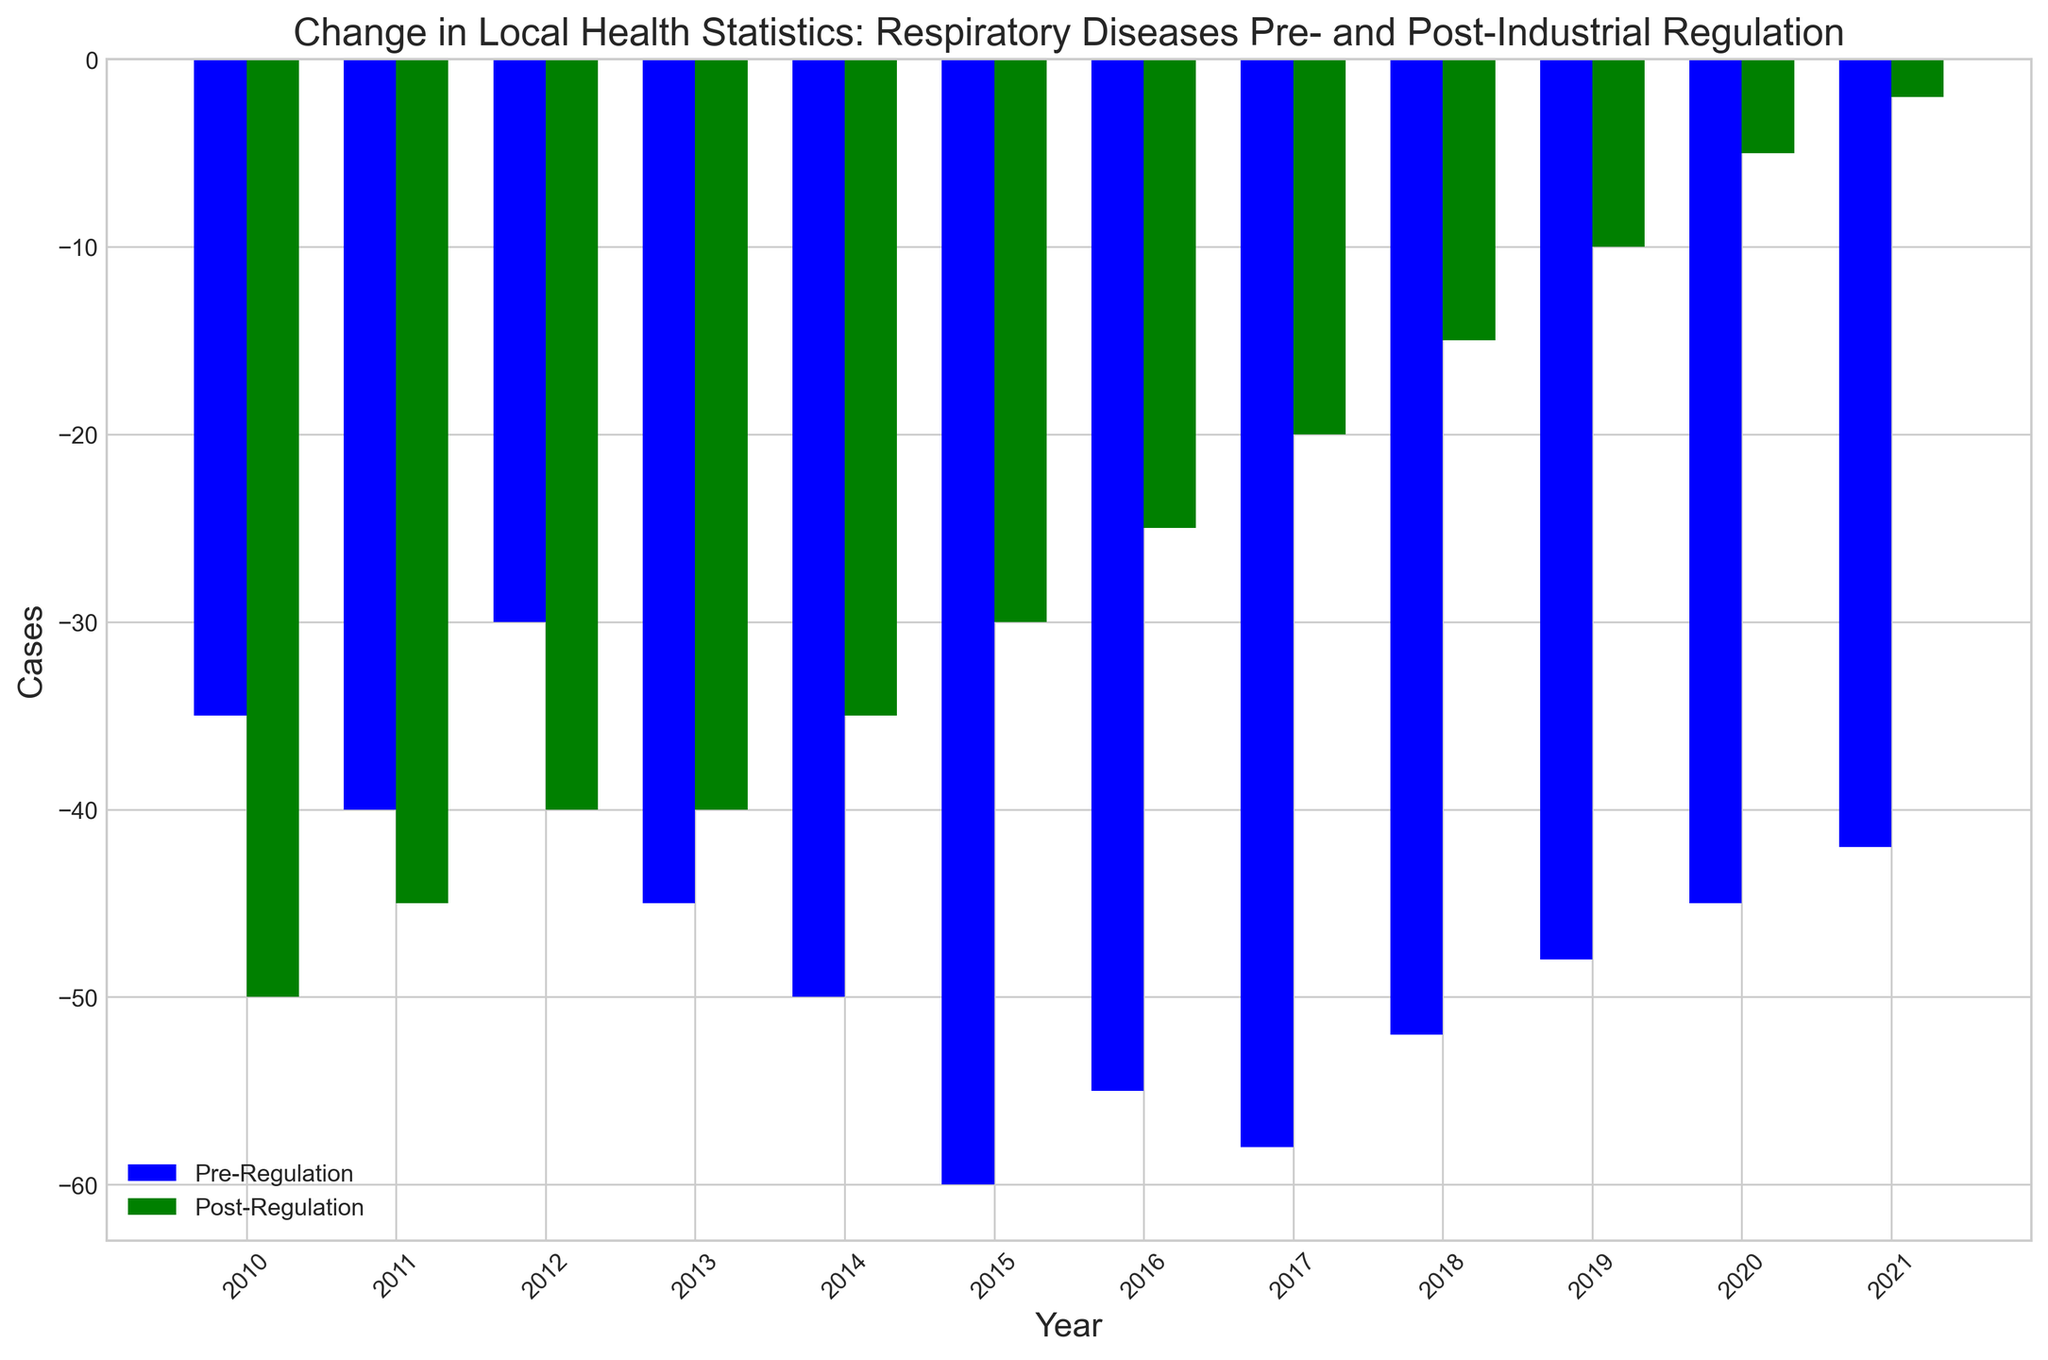What year had the biggest reduction in respiratory disease cases post-regulation compared to the year before? To determine the year with the biggest reduction, compare the difference in post-regulation values between consecutive years. Calculate the difference: (2011-2010), (2012-2011), etc. The difference is greatest from -5 in 2020 to -2 in 2021.
Answer: 2021 Which year shows the largest improvement in respiratory disease cases from pre-regulation to post-regulation? To find the year with the largest improvement, subtract each year's post-regulation value from the pre-regulation value and identify the maximum difference. The differences are: (2010:15), (2011:5), ..., (2021:40).
Answer: 2021 What is the average number of respiratory disease cases pre-regulation for the years shown? Sum all pre-regulation values and divide by the number of years (12): (-35 - 40 - 30 - 45 - 50 - 60 - 55 - 58 - 52 - 48 - 45 - 42) / 12. The sum is -560 and the average is -560 / 12 = -46.67.
Answer: -46.67 How much lower were the respiratory disease cases post-regulation in 2015 compared to pre-regulation the same year? Subtract the post-regulation value for 2015 from the pre-regulation value for 2015: -30 - (-60) = 30.
Answer: 30 In which year do respiratory disease cases pre-regulation and post-regulation have the smallest difference? Calculate the absolute differences for each year and identify the smallest: (2010:15), (2011:5), ..., (2021:40). The smallest difference is in 2011:
Answer: 2011 Which year had the second-highest number of post-regulation cases? List the post-regulation values and identify the second-highest: -50, -45, ..., -2. The second-highest value is -5 in 2020.
Answer: 2020 What are the overall trends of respiratory disease cases pre- and post-regulation over the years? The pre-regulation cases generally increase in magnitude (more negative), while post-regulation cases decrease in magnitude (less negative). Visually, the pre-regulation bars mostly decrease in height, and the post-regulation bars mostly increase in height over time.
Answer: Decreasing (Pre), Increasing (Post) By what percentage did respiratory disease cases improve from pre- to post-regulation in 2021? Calculate the percentage change: ((-42 - (-2)) / -42) * 100 = (40 / 42) * 100 ≈ 95.24%.
Answer: 95.24% What was the percentage decrease in post-regulation cases from 2018 to 2019? Calculate the percentage decrease: ((-10 - (-15)) / -15) * 100 = (5 / 15) * 100 ≈ 33.33%.
Answer: 33.33% Between which two consecutive years was the smallest change in post-regulation cases observed? Calculate the absolute differences for post-regulation values between consecutive years: abs(-45-(-50)), abs(-40-(-45)), ... The smallest change is between 2012 (-40) and 2013 (-40), which is 0.
Answer: 2012 to 2013 